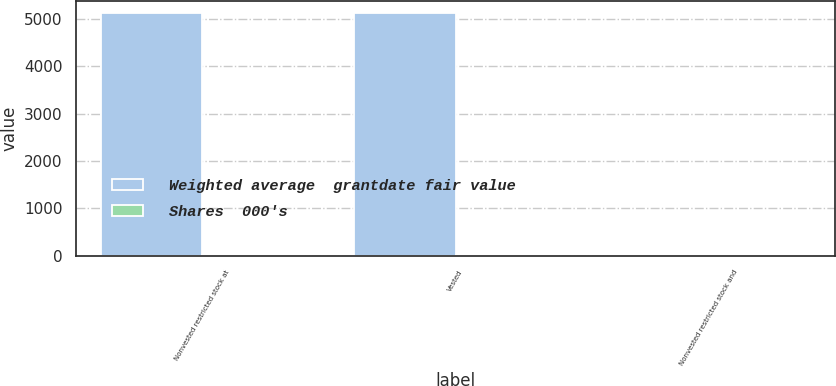Convert chart. <chart><loc_0><loc_0><loc_500><loc_500><stacked_bar_chart><ecel><fcel>Nonvested restricted stock at<fcel>Vested<fcel>Nonvested restricted stock and<nl><fcel>Weighted average  grantdate fair value<fcel>5134<fcel>5134<fcel>0<nl><fcel>Shares  000's<fcel>8.67<fcel>8.67<fcel>0<nl></chart> 